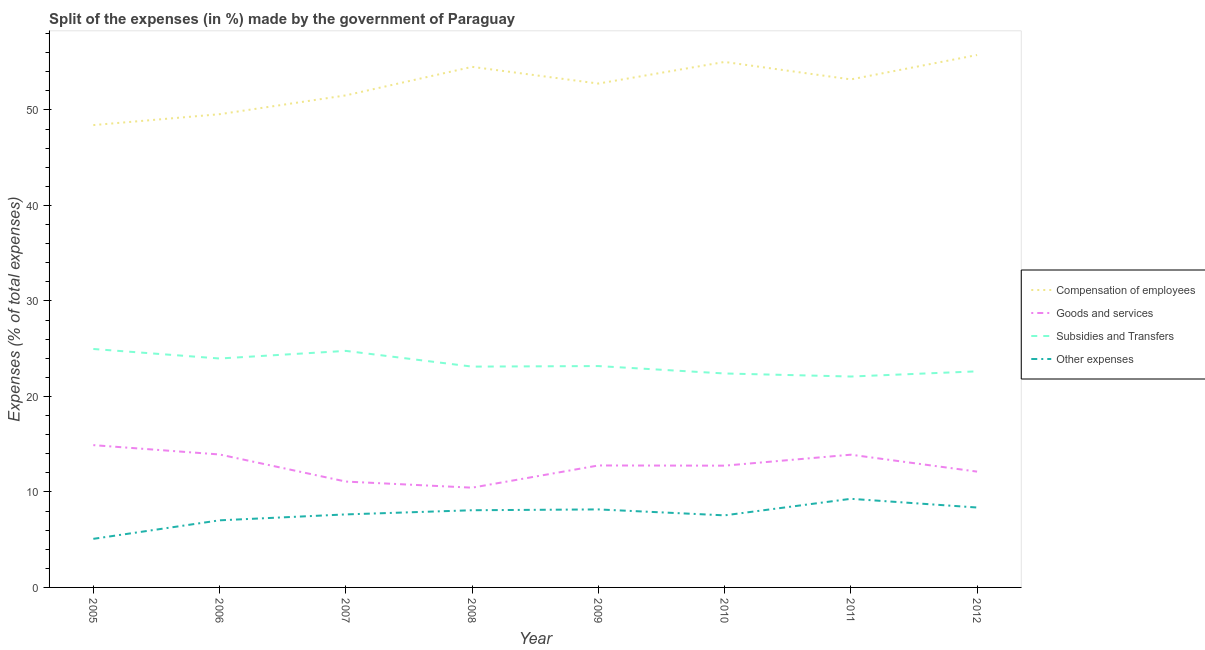Is the number of lines equal to the number of legend labels?
Provide a short and direct response. Yes. What is the percentage of amount spent on subsidies in 2005?
Give a very brief answer. 24.97. Across all years, what is the maximum percentage of amount spent on subsidies?
Provide a succinct answer. 24.97. Across all years, what is the minimum percentage of amount spent on other expenses?
Your answer should be very brief. 5.09. In which year was the percentage of amount spent on other expenses minimum?
Keep it short and to the point. 2005. What is the total percentage of amount spent on goods and services in the graph?
Offer a terse response. 101.9. What is the difference between the percentage of amount spent on subsidies in 2005 and that in 2007?
Your response must be concise. 0.2. What is the difference between the percentage of amount spent on goods and services in 2009 and the percentage of amount spent on compensation of employees in 2006?
Keep it short and to the point. -36.78. What is the average percentage of amount spent on goods and services per year?
Your answer should be compact. 12.74. In the year 2006, what is the difference between the percentage of amount spent on goods and services and percentage of amount spent on compensation of employees?
Provide a short and direct response. -35.63. What is the ratio of the percentage of amount spent on compensation of employees in 2006 to that in 2010?
Offer a very short reply. 0.9. Is the percentage of amount spent on compensation of employees in 2006 less than that in 2007?
Make the answer very short. Yes. What is the difference between the highest and the second highest percentage of amount spent on other expenses?
Offer a terse response. 0.91. What is the difference between the highest and the lowest percentage of amount spent on compensation of employees?
Give a very brief answer. 7.34. In how many years, is the percentage of amount spent on compensation of employees greater than the average percentage of amount spent on compensation of employees taken over all years?
Ensure brevity in your answer.  5. Is it the case that in every year, the sum of the percentage of amount spent on goods and services and percentage of amount spent on subsidies is greater than the sum of percentage of amount spent on other expenses and percentage of amount spent on compensation of employees?
Keep it short and to the point. No. Is the percentage of amount spent on compensation of employees strictly less than the percentage of amount spent on goods and services over the years?
Make the answer very short. No. Does the graph contain grids?
Ensure brevity in your answer.  No. How many legend labels are there?
Your response must be concise. 4. How are the legend labels stacked?
Your answer should be compact. Vertical. What is the title of the graph?
Offer a very short reply. Split of the expenses (in %) made by the government of Paraguay. Does "Quality of public administration" appear as one of the legend labels in the graph?
Offer a terse response. No. What is the label or title of the Y-axis?
Provide a short and direct response. Expenses (% of total expenses). What is the Expenses (% of total expenses) of Compensation of employees in 2005?
Ensure brevity in your answer.  48.42. What is the Expenses (% of total expenses) in Goods and services in 2005?
Ensure brevity in your answer.  14.9. What is the Expenses (% of total expenses) of Subsidies and Transfers in 2005?
Keep it short and to the point. 24.97. What is the Expenses (% of total expenses) of Other expenses in 2005?
Your answer should be compact. 5.09. What is the Expenses (% of total expenses) of Compensation of employees in 2006?
Offer a terse response. 49.56. What is the Expenses (% of total expenses) of Goods and services in 2006?
Keep it short and to the point. 13.92. What is the Expenses (% of total expenses) in Subsidies and Transfers in 2006?
Ensure brevity in your answer.  23.97. What is the Expenses (% of total expenses) in Other expenses in 2006?
Keep it short and to the point. 7.03. What is the Expenses (% of total expenses) of Compensation of employees in 2007?
Ensure brevity in your answer.  51.53. What is the Expenses (% of total expenses) of Goods and services in 2007?
Offer a very short reply. 11.09. What is the Expenses (% of total expenses) in Subsidies and Transfers in 2007?
Your answer should be very brief. 24.77. What is the Expenses (% of total expenses) in Other expenses in 2007?
Provide a succinct answer. 7.65. What is the Expenses (% of total expenses) of Compensation of employees in 2008?
Offer a very short reply. 54.52. What is the Expenses (% of total expenses) in Goods and services in 2008?
Make the answer very short. 10.45. What is the Expenses (% of total expenses) in Subsidies and Transfers in 2008?
Your answer should be compact. 23.12. What is the Expenses (% of total expenses) of Other expenses in 2008?
Your answer should be compact. 8.08. What is the Expenses (% of total expenses) in Compensation of employees in 2009?
Your answer should be very brief. 52.77. What is the Expenses (% of total expenses) of Goods and services in 2009?
Give a very brief answer. 12.77. What is the Expenses (% of total expenses) of Subsidies and Transfers in 2009?
Provide a succinct answer. 23.18. What is the Expenses (% of total expenses) of Other expenses in 2009?
Give a very brief answer. 8.17. What is the Expenses (% of total expenses) in Compensation of employees in 2010?
Your answer should be very brief. 55.03. What is the Expenses (% of total expenses) in Goods and services in 2010?
Your response must be concise. 12.75. What is the Expenses (% of total expenses) of Subsidies and Transfers in 2010?
Offer a very short reply. 22.4. What is the Expenses (% of total expenses) of Other expenses in 2010?
Ensure brevity in your answer.  7.55. What is the Expenses (% of total expenses) in Compensation of employees in 2011?
Offer a terse response. 53.2. What is the Expenses (% of total expenses) in Goods and services in 2011?
Provide a short and direct response. 13.9. What is the Expenses (% of total expenses) in Subsidies and Transfers in 2011?
Your answer should be compact. 22.09. What is the Expenses (% of total expenses) in Other expenses in 2011?
Offer a terse response. 9.28. What is the Expenses (% of total expenses) in Compensation of employees in 2012?
Offer a terse response. 55.75. What is the Expenses (% of total expenses) of Goods and services in 2012?
Provide a succinct answer. 12.13. What is the Expenses (% of total expenses) in Subsidies and Transfers in 2012?
Your answer should be very brief. 22.63. What is the Expenses (% of total expenses) in Other expenses in 2012?
Ensure brevity in your answer.  8.37. Across all years, what is the maximum Expenses (% of total expenses) of Compensation of employees?
Provide a succinct answer. 55.75. Across all years, what is the maximum Expenses (% of total expenses) of Goods and services?
Provide a short and direct response. 14.9. Across all years, what is the maximum Expenses (% of total expenses) of Subsidies and Transfers?
Your answer should be compact. 24.97. Across all years, what is the maximum Expenses (% of total expenses) in Other expenses?
Your answer should be very brief. 9.28. Across all years, what is the minimum Expenses (% of total expenses) in Compensation of employees?
Provide a short and direct response. 48.42. Across all years, what is the minimum Expenses (% of total expenses) in Goods and services?
Ensure brevity in your answer.  10.45. Across all years, what is the minimum Expenses (% of total expenses) of Subsidies and Transfers?
Offer a terse response. 22.09. Across all years, what is the minimum Expenses (% of total expenses) in Other expenses?
Keep it short and to the point. 5.09. What is the total Expenses (% of total expenses) of Compensation of employees in the graph?
Give a very brief answer. 420.76. What is the total Expenses (% of total expenses) of Goods and services in the graph?
Offer a very short reply. 101.9. What is the total Expenses (% of total expenses) in Subsidies and Transfers in the graph?
Ensure brevity in your answer.  187.14. What is the total Expenses (% of total expenses) of Other expenses in the graph?
Your answer should be compact. 61.21. What is the difference between the Expenses (% of total expenses) in Compensation of employees in 2005 and that in 2006?
Your response must be concise. -1.14. What is the difference between the Expenses (% of total expenses) of Subsidies and Transfers in 2005 and that in 2006?
Give a very brief answer. 1. What is the difference between the Expenses (% of total expenses) in Other expenses in 2005 and that in 2006?
Provide a succinct answer. -1.94. What is the difference between the Expenses (% of total expenses) in Compensation of employees in 2005 and that in 2007?
Provide a short and direct response. -3.11. What is the difference between the Expenses (% of total expenses) in Goods and services in 2005 and that in 2007?
Your answer should be very brief. 3.82. What is the difference between the Expenses (% of total expenses) in Subsidies and Transfers in 2005 and that in 2007?
Your answer should be very brief. 0.2. What is the difference between the Expenses (% of total expenses) in Other expenses in 2005 and that in 2007?
Ensure brevity in your answer.  -2.56. What is the difference between the Expenses (% of total expenses) of Compensation of employees in 2005 and that in 2008?
Your answer should be compact. -6.1. What is the difference between the Expenses (% of total expenses) in Goods and services in 2005 and that in 2008?
Your answer should be very brief. 4.46. What is the difference between the Expenses (% of total expenses) of Subsidies and Transfers in 2005 and that in 2008?
Provide a short and direct response. 1.85. What is the difference between the Expenses (% of total expenses) in Other expenses in 2005 and that in 2008?
Provide a succinct answer. -3. What is the difference between the Expenses (% of total expenses) in Compensation of employees in 2005 and that in 2009?
Provide a short and direct response. -4.35. What is the difference between the Expenses (% of total expenses) of Goods and services in 2005 and that in 2009?
Ensure brevity in your answer.  2.13. What is the difference between the Expenses (% of total expenses) of Subsidies and Transfers in 2005 and that in 2009?
Your answer should be very brief. 1.79. What is the difference between the Expenses (% of total expenses) of Other expenses in 2005 and that in 2009?
Provide a short and direct response. -3.08. What is the difference between the Expenses (% of total expenses) in Compensation of employees in 2005 and that in 2010?
Your response must be concise. -6.61. What is the difference between the Expenses (% of total expenses) of Goods and services in 2005 and that in 2010?
Offer a terse response. 2.15. What is the difference between the Expenses (% of total expenses) in Subsidies and Transfers in 2005 and that in 2010?
Provide a short and direct response. 2.56. What is the difference between the Expenses (% of total expenses) of Other expenses in 2005 and that in 2010?
Make the answer very short. -2.46. What is the difference between the Expenses (% of total expenses) in Compensation of employees in 2005 and that in 2011?
Give a very brief answer. -4.78. What is the difference between the Expenses (% of total expenses) of Goods and services in 2005 and that in 2011?
Ensure brevity in your answer.  1. What is the difference between the Expenses (% of total expenses) in Subsidies and Transfers in 2005 and that in 2011?
Give a very brief answer. 2.88. What is the difference between the Expenses (% of total expenses) of Other expenses in 2005 and that in 2011?
Your answer should be compact. -4.19. What is the difference between the Expenses (% of total expenses) of Compensation of employees in 2005 and that in 2012?
Your answer should be compact. -7.34. What is the difference between the Expenses (% of total expenses) in Goods and services in 2005 and that in 2012?
Offer a very short reply. 2.77. What is the difference between the Expenses (% of total expenses) of Subsidies and Transfers in 2005 and that in 2012?
Your answer should be very brief. 2.34. What is the difference between the Expenses (% of total expenses) of Other expenses in 2005 and that in 2012?
Your response must be concise. -3.28. What is the difference between the Expenses (% of total expenses) in Compensation of employees in 2006 and that in 2007?
Ensure brevity in your answer.  -1.97. What is the difference between the Expenses (% of total expenses) in Goods and services in 2006 and that in 2007?
Your response must be concise. 2.84. What is the difference between the Expenses (% of total expenses) of Subsidies and Transfers in 2006 and that in 2007?
Keep it short and to the point. -0.8. What is the difference between the Expenses (% of total expenses) of Other expenses in 2006 and that in 2007?
Offer a very short reply. -0.62. What is the difference between the Expenses (% of total expenses) in Compensation of employees in 2006 and that in 2008?
Give a very brief answer. -4.96. What is the difference between the Expenses (% of total expenses) in Goods and services in 2006 and that in 2008?
Provide a succinct answer. 3.48. What is the difference between the Expenses (% of total expenses) of Subsidies and Transfers in 2006 and that in 2008?
Ensure brevity in your answer.  0.85. What is the difference between the Expenses (% of total expenses) in Other expenses in 2006 and that in 2008?
Provide a succinct answer. -1.06. What is the difference between the Expenses (% of total expenses) in Compensation of employees in 2006 and that in 2009?
Your answer should be compact. -3.21. What is the difference between the Expenses (% of total expenses) in Goods and services in 2006 and that in 2009?
Provide a short and direct response. 1.15. What is the difference between the Expenses (% of total expenses) of Subsidies and Transfers in 2006 and that in 2009?
Give a very brief answer. 0.79. What is the difference between the Expenses (% of total expenses) of Other expenses in 2006 and that in 2009?
Ensure brevity in your answer.  -1.14. What is the difference between the Expenses (% of total expenses) of Compensation of employees in 2006 and that in 2010?
Keep it short and to the point. -5.47. What is the difference between the Expenses (% of total expenses) in Goods and services in 2006 and that in 2010?
Provide a succinct answer. 1.17. What is the difference between the Expenses (% of total expenses) of Subsidies and Transfers in 2006 and that in 2010?
Your answer should be compact. 1.57. What is the difference between the Expenses (% of total expenses) in Other expenses in 2006 and that in 2010?
Provide a short and direct response. -0.52. What is the difference between the Expenses (% of total expenses) in Compensation of employees in 2006 and that in 2011?
Your answer should be very brief. -3.64. What is the difference between the Expenses (% of total expenses) of Goods and services in 2006 and that in 2011?
Your response must be concise. 0.02. What is the difference between the Expenses (% of total expenses) in Subsidies and Transfers in 2006 and that in 2011?
Offer a terse response. 1.89. What is the difference between the Expenses (% of total expenses) in Other expenses in 2006 and that in 2011?
Give a very brief answer. -2.25. What is the difference between the Expenses (% of total expenses) in Compensation of employees in 2006 and that in 2012?
Give a very brief answer. -6.2. What is the difference between the Expenses (% of total expenses) in Goods and services in 2006 and that in 2012?
Your response must be concise. 1.8. What is the difference between the Expenses (% of total expenses) in Subsidies and Transfers in 2006 and that in 2012?
Provide a short and direct response. 1.34. What is the difference between the Expenses (% of total expenses) in Other expenses in 2006 and that in 2012?
Provide a short and direct response. -1.34. What is the difference between the Expenses (% of total expenses) in Compensation of employees in 2007 and that in 2008?
Provide a succinct answer. -2.99. What is the difference between the Expenses (% of total expenses) of Goods and services in 2007 and that in 2008?
Make the answer very short. 0.64. What is the difference between the Expenses (% of total expenses) of Subsidies and Transfers in 2007 and that in 2008?
Keep it short and to the point. 1.65. What is the difference between the Expenses (% of total expenses) in Other expenses in 2007 and that in 2008?
Keep it short and to the point. -0.44. What is the difference between the Expenses (% of total expenses) in Compensation of employees in 2007 and that in 2009?
Your response must be concise. -1.24. What is the difference between the Expenses (% of total expenses) of Goods and services in 2007 and that in 2009?
Offer a terse response. -1.69. What is the difference between the Expenses (% of total expenses) in Subsidies and Transfers in 2007 and that in 2009?
Your answer should be compact. 1.59. What is the difference between the Expenses (% of total expenses) in Other expenses in 2007 and that in 2009?
Your answer should be compact. -0.52. What is the difference between the Expenses (% of total expenses) of Compensation of employees in 2007 and that in 2010?
Keep it short and to the point. -3.5. What is the difference between the Expenses (% of total expenses) in Goods and services in 2007 and that in 2010?
Provide a short and direct response. -1.67. What is the difference between the Expenses (% of total expenses) in Subsidies and Transfers in 2007 and that in 2010?
Make the answer very short. 2.37. What is the difference between the Expenses (% of total expenses) of Other expenses in 2007 and that in 2010?
Keep it short and to the point. 0.1. What is the difference between the Expenses (% of total expenses) in Compensation of employees in 2007 and that in 2011?
Offer a terse response. -1.67. What is the difference between the Expenses (% of total expenses) in Goods and services in 2007 and that in 2011?
Offer a terse response. -2.81. What is the difference between the Expenses (% of total expenses) of Subsidies and Transfers in 2007 and that in 2011?
Keep it short and to the point. 2.69. What is the difference between the Expenses (% of total expenses) in Other expenses in 2007 and that in 2011?
Give a very brief answer. -1.63. What is the difference between the Expenses (% of total expenses) of Compensation of employees in 2007 and that in 2012?
Your answer should be very brief. -4.23. What is the difference between the Expenses (% of total expenses) of Goods and services in 2007 and that in 2012?
Offer a terse response. -1.04. What is the difference between the Expenses (% of total expenses) in Subsidies and Transfers in 2007 and that in 2012?
Provide a short and direct response. 2.14. What is the difference between the Expenses (% of total expenses) in Other expenses in 2007 and that in 2012?
Ensure brevity in your answer.  -0.72. What is the difference between the Expenses (% of total expenses) of Compensation of employees in 2008 and that in 2009?
Make the answer very short. 1.75. What is the difference between the Expenses (% of total expenses) of Goods and services in 2008 and that in 2009?
Provide a short and direct response. -2.33. What is the difference between the Expenses (% of total expenses) of Subsidies and Transfers in 2008 and that in 2009?
Offer a very short reply. -0.06. What is the difference between the Expenses (% of total expenses) of Other expenses in 2008 and that in 2009?
Ensure brevity in your answer.  -0.09. What is the difference between the Expenses (% of total expenses) in Compensation of employees in 2008 and that in 2010?
Ensure brevity in your answer.  -0.51. What is the difference between the Expenses (% of total expenses) of Goods and services in 2008 and that in 2010?
Offer a terse response. -2.31. What is the difference between the Expenses (% of total expenses) of Subsidies and Transfers in 2008 and that in 2010?
Keep it short and to the point. 0.72. What is the difference between the Expenses (% of total expenses) of Other expenses in 2008 and that in 2010?
Your response must be concise. 0.54. What is the difference between the Expenses (% of total expenses) of Compensation of employees in 2008 and that in 2011?
Provide a short and direct response. 1.32. What is the difference between the Expenses (% of total expenses) in Goods and services in 2008 and that in 2011?
Your answer should be compact. -3.45. What is the difference between the Expenses (% of total expenses) of Subsidies and Transfers in 2008 and that in 2011?
Your answer should be compact. 1.04. What is the difference between the Expenses (% of total expenses) in Other expenses in 2008 and that in 2011?
Provide a short and direct response. -1.2. What is the difference between the Expenses (% of total expenses) in Compensation of employees in 2008 and that in 2012?
Offer a terse response. -1.24. What is the difference between the Expenses (% of total expenses) of Goods and services in 2008 and that in 2012?
Provide a short and direct response. -1.68. What is the difference between the Expenses (% of total expenses) in Subsidies and Transfers in 2008 and that in 2012?
Ensure brevity in your answer.  0.5. What is the difference between the Expenses (% of total expenses) of Other expenses in 2008 and that in 2012?
Offer a terse response. -0.29. What is the difference between the Expenses (% of total expenses) of Compensation of employees in 2009 and that in 2010?
Provide a short and direct response. -2.26. What is the difference between the Expenses (% of total expenses) of Goods and services in 2009 and that in 2010?
Give a very brief answer. 0.02. What is the difference between the Expenses (% of total expenses) of Subsidies and Transfers in 2009 and that in 2010?
Provide a succinct answer. 0.78. What is the difference between the Expenses (% of total expenses) in Other expenses in 2009 and that in 2010?
Make the answer very short. 0.62. What is the difference between the Expenses (% of total expenses) in Compensation of employees in 2009 and that in 2011?
Offer a terse response. -0.43. What is the difference between the Expenses (% of total expenses) in Goods and services in 2009 and that in 2011?
Your answer should be compact. -1.13. What is the difference between the Expenses (% of total expenses) of Subsidies and Transfers in 2009 and that in 2011?
Offer a terse response. 1.1. What is the difference between the Expenses (% of total expenses) of Other expenses in 2009 and that in 2011?
Give a very brief answer. -1.11. What is the difference between the Expenses (% of total expenses) of Compensation of employees in 2009 and that in 2012?
Your response must be concise. -2.99. What is the difference between the Expenses (% of total expenses) of Goods and services in 2009 and that in 2012?
Make the answer very short. 0.64. What is the difference between the Expenses (% of total expenses) of Subsidies and Transfers in 2009 and that in 2012?
Provide a short and direct response. 0.55. What is the difference between the Expenses (% of total expenses) in Other expenses in 2009 and that in 2012?
Your answer should be compact. -0.2. What is the difference between the Expenses (% of total expenses) in Compensation of employees in 2010 and that in 2011?
Keep it short and to the point. 1.83. What is the difference between the Expenses (% of total expenses) of Goods and services in 2010 and that in 2011?
Offer a very short reply. -1.15. What is the difference between the Expenses (% of total expenses) in Subsidies and Transfers in 2010 and that in 2011?
Your answer should be very brief. 0.32. What is the difference between the Expenses (% of total expenses) in Other expenses in 2010 and that in 2011?
Your answer should be compact. -1.73. What is the difference between the Expenses (% of total expenses) in Compensation of employees in 2010 and that in 2012?
Keep it short and to the point. -0.73. What is the difference between the Expenses (% of total expenses) in Goods and services in 2010 and that in 2012?
Offer a terse response. 0.62. What is the difference between the Expenses (% of total expenses) in Subsidies and Transfers in 2010 and that in 2012?
Provide a succinct answer. -0.22. What is the difference between the Expenses (% of total expenses) of Other expenses in 2010 and that in 2012?
Offer a terse response. -0.82. What is the difference between the Expenses (% of total expenses) in Compensation of employees in 2011 and that in 2012?
Make the answer very short. -2.55. What is the difference between the Expenses (% of total expenses) of Goods and services in 2011 and that in 2012?
Your response must be concise. 1.77. What is the difference between the Expenses (% of total expenses) in Subsidies and Transfers in 2011 and that in 2012?
Give a very brief answer. -0.54. What is the difference between the Expenses (% of total expenses) in Other expenses in 2011 and that in 2012?
Offer a very short reply. 0.91. What is the difference between the Expenses (% of total expenses) in Compensation of employees in 2005 and the Expenses (% of total expenses) in Goods and services in 2006?
Provide a short and direct response. 34.49. What is the difference between the Expenses (% of total expenses) of Compensation of employees in 2005 and the Expenses (% of total expenses) of Subsidies and Transfers in 2006?
Your answer should be compact. 24.44. What is the difference between the Expenses (% of total expenses) in Compensation of employees in 2005 and the Expenses (% of total expenses) in Other expenses in 2006?
Make the answer very short. 41.39. What is the difference between the Expenses (% of total expenses) in Goods and services in 2005 and the Expenses (% of total expenses) in Subsidies and Transfers in 2006?
Provide a succinct answer. -9.07. What is the difference between the Expenses (% of total expenses) in Goods and services in 2005 and the Expenses (% of total expenses) in Other expenses in 2006?
Ensure brevity in your answer.  7.87. What is the difference between the Expenses (% of total expenses) of Subsidies and Transfers in 2005 and the Expenses (% of total expenses) of Other expenses in 2006?
Provide a succinct answer. 17.94. What is the difference between the Expenses (% of total expenses) of Compensation of employees in 2005 and the Expenses (% of total expenses) of Goods and services in 2007?
Offer a very short reply. 37.33. What is the difference between the Expenses (% of total expenses) of Compensation of employees in 2005 and the Expenses (% of total expenses) of Subsidies and Transfers in 2007?
Your answer should be compact. 23.64. What is the difference between the Expenses (% of total expenses) of Compensation of employees in 2005 and the Expenses (% of total expenses) of Other expenses in 2007?
Keep it short and to the point. 40.77. What is the difference between the Expenses (% of total expenses) of Goods and services in 2005 and the Expenses (% of total expenses) of Subsidies and Transfers in 2007?
Your response must be concise. -9.87. What is the difference between the Expenses (% of total expenses) of Goods and services in 2005 and the Expenses (% of total expenses) of Other expenses in 2007?
Your answer should be very brief. 7.25. What is the difference between the Expenses (% of total expenses) of Subsidies and Transfers in 2005 and the Expenses (% of total expenses) of Other expenses in 2007?
Give a very brief answer. 17.32. What is the difference between the Expenses (% of total expenses) of Compensation of employees in 2005 and the Expenses (% of total expenses) of Goods and services in 2008?
Your answer should be compact. 37.97. What is the difference between the Expenses (% of total expenses) of Compensation of employees in 2005 and the Expenses (% of total expenses) of Subsidies and Transfers in 2008?
Provide a short and direct response. 25.29. What is the difference between the Expenses (% of total expenses) in Compensation of employees in 2005 and the Expenses (% of total expenses) in Other expenses in 2008?
Give a very brief answer. 40.33. What is the difference between the Expenses (% of total expenses) in Goods and services in 2005 and the Expenses (% of total expenses) in Subsidies and Transfers in 2008?
Make the answer very short. -8.22. What is the difference between the Expenses (% of total expenses) in Goods and services in 2005 and the Expenses (% of total expenses) in Other expenses in 2008?
Your answer should be very brief. 6.82. What is the difference between the Expenses (% of total expenses) of Subsidies and Transfers in 2005 and the Expenses (% of total expenses) of Other expenses in 2008?
Your answer should be compact. 16.89. What is the difference between the Expenses (% of total expenses) in Compensation of employees in 2005 and the Expenses (% of total expenses) in Goods and services in 2009?
Your answer should be very brief. 35.64. What is the difference between the Expenses (% of total expenses) in Compensation of employees in 2005 and the Expenses (% of total expenses) in Subsidies and Transfers in 2009?
Ensure brevity in your answer.  25.23. What is the difference between the Expenses (% of total expenses) of Compensation of employees in 2005 and the Expenses (% of total expenses) of Other expenses in 2009?
Make the answer very short. 40.25. What is the difference between the Expenses (% of total expenses) in Goods and services in 2005 and the Expenses (% of total expenses) in Subsidies and Transfers in 2009?
Your response must be concise. -8.28. What is the difference between the Expenses (% of total expenses) in Goods and services in 2005 and the Expenses (% of total expenses) in Other expenses in 2009?
Provide a short and direct response. 6.73. What is the difference between the Expenses (% of total expenses) in Subsidies and Transfers in 2005 and the Expenses (% of total expenses) in Other expenses in 2009?
Your answer should be compact. 16.8. What is the difference between the Expenses (% of total expenses) of Compensation of employees in 2005 and the Expenses (% of total expenses) of Goods and services in 2010?
Your answer should be very brief. 35.66. What is the difference between the Expenses (% of total expenses) of Compensation of employees in 2005 and the Expenses (% of total expenses) of Subsidies and Transfers in 2010?
Keep it short and to the point. 26.01. What is the difference between the Expenses (% of total expenses) of Compensation of employees in 2005 and the Expenses (% of total expenses) of Other expenses in 2010?
Ensure brevity in your answer.  40.87. What is the difference between the Expenses (% of total expenses) in Goods and services in 2005 and the Expenses (% of total expenses) in Subsidies and Transfers in 2010?
Your answer should be compact. -7.5. What is the difference between the Expenses (% of total expenses) of Goods and services in 2005 and the Expenses (% of total expenses) of Other expenses in 2010?
Keep it short and to the point. 7.35. What is the difference between the Expenses (% of total expenses) in Subsidies and Transfers in 2005 and the Expenses (% of total expenses) in Other expenses in 2010?
Your response must be concise. 17.42. What is the difference between the Expenses (% of total expenses) in Compensation of employees in 2005 and the Expenses (% of total expenses) in Goods and services in 2011?
Provide a succinct answer. 34.52. What is the difference between the Expenses (% of total expenses) in Compensation of employees in 2005 and the Expenses (% of total expenses) in Subsidies and Transfers in 2011?
Provide a succinct answer. 26.33. What is the difference between the Expenses (% of total expenses) of Compensation of employees in 2005 and the Expenses (% of total expenses) of Other expenses in 2011?
Keep it short and to the point. 39.14. What is the difference between the Expenses (% of total expenses) of Goods and services in 2005 and the Expenses (% of total expenses) of Subsidies and Transfers in 2011?
Give a very brief answer. -7.18. What is the difference between the Expenses (% of total expenses) in Goods and services in 2005 and the Expenses (% of total expenses) in Other expenses in 2011?
Offer a terse response. 5.62. What is the difference between the Expenses (% of total expenses) in Subsidies and Transfers in 2005 and the Expenses (% of total expenses) in Other expenses in 2011?
Your answer should be very brief. 15.69. What is the difference between the Expenses (% of total expenses) in Compensation of employees in 2005 and the Expenses (% of total expenses) in Goods and services in 2012?
Keep it short and to the point. 36.29. What is the difference between the Expenses (% of total expenses) of Compensation of employees in 2005 and the Expenses (% of total expenses) of Subsidies and Transfers in 2012?
Offer a very short reply. 25.79. What is the difference between the Expenses (% of total expenses) of Compensation of employees in 2005 and the Expenses (% of total expenses) of Other expenses in 2012?
Ensure brevity in your answer.  40.05. What is the difference between the Expenses (% of total expenses) of Goods and services in 2005 and the Expenses (% of total expenses) of Subsidies and Transfers in 2012?
Your answer should be very brief. -7.73. What is the difference between the Expenses (% of total expenses) in Goods and services in 2005 and the Expenses (% of total expenses) in Other expenses in 2012?
Provide a short and direct response. 6.53. What is the difference between the Expenses (% of total expenses) in Subsidies and Transfers in 2005 and the Expenses (% of total expenses) in Other expenses in 2012?
Offer a terse response. 16.6. What is the difference between the Expenses (% of total expenses) in Compensation of employees in 2006 and the Expenses (% of total expenses) in Goods and services in 2007?
Give a very brief answer. 38.47. What is the difference between the Expenses (% of total expenses) in Compensation of employees in 2006 and the Expenses (% of total expenses) in Subsidies and Transfers in 2007?
Your answer should be very brief. 24.78. What is the difference between the Expenses (% of total expenses) of Compensation of employees in 2006 and the Expenses (% of total expenses) of Other expenses in 2007?
Make the answer very short. 41.91. What is the difference between the Expenses (% of total expenses) in Goods and services in 2006 and the Expenses (% of total expenses) in Subsidies and Transfers in 2007?
Give a very brief answer. -10.85. What is the difference between the Expenses (% of total expenses) in Goods and services in 2006 and the Expenses (% of total expenses) in Other expenses in 2007?
Your answer should be compact. 6.28. What is the difference between the Expenses (% of total expenses) of Subsidies and Transfers in 2006 and the Expenses (% of total expenses) of Other expenses in 2007?
Ensure brevity in your answer.  16.33. What is the difference between the Expenses (% of total expenses) in Compensation of employees in 2006 and the Expenses (% of total expenses) in Goods and services in 2008?
Provide a succinct answer. 39.11. What is the difference between the Expenses (% of total expenses) of Compensation of employees in 2006 and the Expenses (% of total expenses) of Subsidies and Transfers in 2008?
Provide a short and direct response. 26.43. What is the difference between the Expenses (% of total expenses) in Compensation of employees in 2006 and the Expenses (% of total expenses) in Other expenses in 2008?
Your answer should be compact. 41.47. What is the difference between the Expenses (% of total expenses) of Goods and services in 2006 and the Expenses (% of total expenses) of Subsidies and Transfers in 2008?
Offer a terse response. -9.2. What is the difference between the Expenses (% of total expenses) in Goods and services in 2006 and the Expenses (% of total expenses) in Other expenses in 2008?
Your answer should be very brief. 5.84. What is the difference between the Expenses (% of total expenses) in Subsidies and Transfers in 2006 and the Expenses (% of total expenses) in Other expenses in 2008?
Provide a succinct answer. 15.89. What is the difference between the Expenses (% of total expenses) in Compensation of employees in 2006 and the Expenses (% of total expenses) in Goods and services in 2009?
Keep it short and to the point. 36.78. What is the difference between the Expenses (% of total expenses) in Compensation of employees in 2006 and the Expenses (% of total expenses) in Subsidies and Transfers in 2009?
Make the answer very short. 26.37. What is the difference between the Expenses (% of total expenses) of Compensation of employees in 2006 and the Expenses (% of total expenses) of Other expenses in 2009?
Keep it short and to the point. 41.39. What is the difference between the Expenses (% of total expenses) of Goods and services in 2006 and the Expenses (% of total expenses) of Subsidies and Transfers in 2009?
Keep it short and to the point. -9.26. What is the difference between the Expenses (% of total expenses) of Goods and services in 2006 and the Expenses (% of total expenses) of Other expenses in 2009?
Provide a short and direct response. 5.75. What is the difference between the Expenses (% of total expenses) in Subsidies and Transfers in 2006 and the Expenses (% of total expenses) in Other expenses in 2009?
Provide a short and direct response. 15.8. What is the difference between the Expenses (% of total expenses) in Compensation of employees in 2006 and the Expenses (% of total expenses) in Goods and services in 2010?
Provide a succinct answer. 36.8. What is the difference between the Expenses (% of total expenses) in Compensation of employees in 2006 and the Expenses (% of total expenses) in Subsidies and Transfers in 2010?
Keep it short and to the point. 27.15. What is the difference between the Expenses (% of total expenses) in Compensation of employees in 2006 and the Expenses (% of total expenses) in Other expenses in 2010?
Make the answer very short. 42.01. What is the difference between the Expenses (% of total expenses) of Goods and services in 2006 and the Expenses (% of total expenses) of Subsidies and Transfers in 2010?
Your answer should be very brief. -8.48. What is the difference between the Expenses (% of total expenses) in Goods and services in 2006 and the Expenses (% of total expenses) in Other expenses in 2010?
Offer a very short reply. 6.38. What is the difference between the Expenses (% of total expenses) of Subsidies and Transfers in 2006 and the Expenses (% of total expenses) of Other expenses in 2010?
Offer a very short reply. 16.43. What is the difference between the Expenses (% of total expenses) in Compensation of employees in 2006 and the Expenses (% of total expenses) in Goods and services in 2011?
Offer a terse response. 35.66. What is the difference between the Expenses (% of total expenses) of Compensation of employees in 2006 and the Expenses (% of total expenses) of Subsidies and Transfers in 2011?
Make the answer very short. 27.47. What is the difference between the Expenses (% of total expenses) in Compensation of employees in 2006 and the Expenses (% of total expenses) in Other expenses in 2011?
Provide a succinct answer. 40.28. What is the difference between the Expenses (% of total expenses) in Goods and services in 2006 and the Expenses (% of total expenses) in Subsidies and Transfers in 2011?
Keep it short and to the point. -8.16. What is the difference between the Expenses (% of total expenses) in Goods and services in 2006 and the Expenses (% of total expenses) in Other expenses in 2011?
Offer a terse response. 4.64. What is the difference between the Expenses (% of total expenses) of Subsidies and Transfers in 2006 and the Expenses (% of total expenses) of Other expenses in 2011?
Make the answer very short. 14.69. What is the difference between the Expenses (% of total expenses) of Compensation of employees in 2006 and the Expenses (% of total expenses) of Goods and services in 2012?
Make the answer very short. 37.43. What is the difference between the Expenses (% of total expenses) of Compensation of employees in 2006 and the Expenses (% of total expenses) of Subsidies and Transfers in 2012?
Offer a very short reply. 26.93. What is the difference between the Expenses (% of total expenses) in Compensation of employees in 2006 and the Expenses (% of total expenses) in Other expenses in 2012?
Provide a short and direct response. 41.19. What is the difference between the Expenses (% of total expenses) of Goods and services in 2006 and the Expenses (% of total expenses) of Subsidies and Transfers in 2012?
Your answer should be very brief. -8.71. What is the difference between the Expenses (% of total expenses) in Goods and services in 2006 and the Expenses (% of total expenses) in Other expenses in 2012?
Your answer should be compact. 5.55. What is the difference between the Expenses (% of total expenses) in Subsidies and Transfers in 2006 and the Expenses (% of total expenses) in Other expenses in 2012?
Offer a very short reply. 15.6. What is the difference between the Expenses (% of total expenses) of Compensation of employees in 2007 and the Expenses (% of total expenses) of Goods and services in 2008?
Your answer should be compact. 41.08. What is the difference between the Expenses (% of total expenses) of Compensation of employees in 2007 and the Expenses (% of total expenses) of Subsidies and Transfers in 2008?
Keep it short and to the point. 28.4. What is the difference between the Expenses (% of total expenses) of Compensation of employees in 2007 and the Expenses (% of total expenses) of Other expenses in 2008?
Ensure brevity in your answer.  43.44. What is the difference between the Expenses (% of total expenses) of Goods and services in 2007 and the Expenses (% of total expenses) of Subsidies and Transfers in 2008?
Offer a terse response. -12.04. What is the difference between the Expenses (% of total expenses) in Goods and services in 2007 and the Expenses (% of total expenses) in Other expenses in 2008?
Give a very brief answer. 3. What is the difference between the Expenses (% of total expenses) of Subsidies and Transfers in 2007 and the Expenses (% of total expenses) of Other expenses in 2008?
Offer a very short reply. 16.69. What is the difference between the Expenses (% of total expenses) of Compensation of employees in 2007 and the Expenses (% of total expenses) of Goods and services in 2009?
Give a very brief answer. 38.76. What is the difference between the Expenses (% of total expenses) of Compensation of employees in 2007 and the Expenses (% of total expenses) of Subsidies and Transfers in 2009?
Make the answer very short. 28.35. What is the difference between the Expenses (% of total expenses) in Compensation of employees in 2007 and the Expenses (% of total expenses) in Other expenses in 2009?
Offer a terse response. 43.36. What is the difference between the Expenses (% of total expenses) in Goods and services in 2007 and the Expenses (% of total expenses) in Subsidies and Transfers in 2009?
Ensure brevity in your answer.  -12.1. What is the difference between the Expenses (% of total expenses) of Goods and services in 2007 and the Expenses (% of total expenses) of Other expenses in 2009?
Offer a very short reply. 2.92. What is the difference between the Expenses (% of total expenses) of Subsidies and Transfers in 2007 and the Expenses (% of total expenses) of Other expenses in 2009?
Your answer should be compact. 16.6. What is the difference between the Expenses (% of total expenses) in Compensation of employees in 2007 and the Expenses (% of total expenses) in Goods and services in 2010?
Your answer should be compact. 38.78. What is the difference between the Expenses (% of total expenses) of Compensation of employees in 2007 and the Expenses (% of total expenses) of Subsidies and Transfers in 2010?
Give a very brief answer. 29.12. What is the difference between the Expenses (% of total expenses) in Compensation of employees in 2007 and the Expenses (% of total expenses) in Other expenses in 2010?
Your answer should be compact. 43.98. What is the difference between the Expenses (% of total expenses) in Goods and services in 2007 and the Expenses (% of total expenses) in Subsidies and Transfers in 2010?
Provide a succinct answer. -11.32. What is the difference between the Expenses (% of total expenses) of Goods and services in 2007 and the Expenses (% of total expenses) of Other expenses in 2010?
Your answer should be compact. 3.54. What is the difference between the Expenses (% of total expenses) of Subsidies and Transfers in 2007 and the Expenses (% of total expenses) of Other expenses in 2010?
Your response must be concise. 17.22. What is the difference between the Expenses (% of total expenses) in Compensation of employees in 2007 and the Expenses (% of total expenses) in Goods and services in 2011?
Offer a terse response. 37.63. What is the difference between the Expenses (% of total expenses) of Compensation of employees in 2007 and the Expenses (% of total expenses) of Subsidies and Transfers in 2011?
Provide a succinct answer. 29.44. What is the difference between the Expenses (% of total expenses) in Compensation of employees in 2007 and the Expenses (% of total expenses) in Other expenses in 2011?
Keep it short and to the point. 42.25. What is the difference between the Expenses (% of total expenses) in Goods and services in 2007 and the Expenses (% of total expenses) in Subsidies and Transfers in 2011?
Give a very brief answer. -11. What is the difference between the Expenses (% of total expenses) in Goods and services in 2007 and the Expenses (% of total expenses) in Other expenses in 2011?
Keep it short and to the point. 1.81. What is the difference between the Expenses (% of total expenses) in Subsidies and Transfers in 2007 and the Expenses (% of total expenses) in Other expenses in 2011?
Your answer should be very brief. 15.49. What is the difference between the Expenses (% of total expenses) of Compensation of employees in 2007 and the Expenses (% of total expenses) of Goods and services in 2012?
Offer a terse response. 39.4. What is the difference between the Expenses (% of total expenses) of Compensation of employees in 2007 and the Expenses (% of total expenses) of Subsidies and Transfers in 2012?
Offer a very short reply. 28.9. What is the difference between the Expenses (% of total expenses) in Compensation of employees in 2007 and the Expenses (% of total expenses) in Other expenses in 2012?
Provide a short and direct response. 43.16. What is the difference between the Expenses (% of total expenses) in Goods and services in 2007 and the Expenses (% of total expenses) in Subsidies and Transfers in 2012?
Your answer should be compact. -11.54. What is the difference between the Expenses (% of total expenses) in Goods and services in 2007 and the Expenses (% of total expenses) in Other expenses in 2012?
Offer a terse response. 2.72. What is the difference between the Expenses (% of total expenses) of Subsidies and Transfers in 2007 and the Expenses (% of total expenses) of Other expenses in 2012?
Offer a terse response. 16.4. What is the difference between the Expenses (% of total expenses) of Compensation of employees in 2008 and the Expenses (% of total expenses) of Goods and services in 2009?
Ensure brevity in your answer.  41.74. What is the difference between the Expenses (% of total expenses) in Compensation of employees in 2008 and the Expenses (% of total expenses) in Subsidies and Transfers in 2009?
Keep it short and to the point. 31.33. What is the difference between the Expenses (% of total expenses) of Compensation of employees in 2008 and the Expenses (% of total expenses) of Other expenses in 2009?
Provide a succinct answer. 46.35. What is the difference between the Expenses (% of total expenses) of Goods and services in 2008 and the Expenses (% of total expenses) of Subsidies and Transfers in 2009?
Keep it short and to the point. -12.74. What is the difference between the Expenses (% of total expenses) of Goods and services in 2008 and the Expenses (% of total expenses) of Other expenses in 2009?
Provide a succinct answer. 2.28. What is the difference between the Expenses (% of total expenses) in Subsidies and Transfers in 2008 and the Expenses (% of total expenses) in Other expenses in 2009?
Make the answer very short. 14.95. What is the difference between the Expenses (% of total expenses) of Compensation of employees in 2008 and the Expenses (% of total expenses) of Goods and services in 2010?
Provide a short and direct response. 41.76. What is the difference between the Expenses (% of total expenses) in Compensation of employees in 2008 and the Expenses (% of total expenses) in Subsidies and Transfers in 2010?
Ensure brevity in your answer.  32.11. What is the difference between the Expenses (% of total expenses) of Compensation of employees in 2008 and the Expenses (% of total expenses) of Other expenses in 2010?
Your response must be concise. 46.97. What is the difference between the Expenses (% of total expenses) in Goods and services in 2008 and the Expenses (% of total expenses) in Subsidies and Transfers in 2010?
Offer a terse response. -11.96. What is the difference between the Expenses (% of total expenses) of Goods and services in 2008 and the Expenses (% of total expenses) of Other expenses in 2010?
Make the answer very short. 2.9. What is the difference between the Expenses (% of total expenses) in Subsidies and Transfers in 2008 and the Expenses (% of total expenses) in Other expenses in 2010?
Provide a succinct answer. 15.58. What is the difference between the Expenses (% of total expenses) of Compensation of employees in 2008 and the Expenses (% of total expenses) of Goods and services in 2011?
Your response must be concise. 40.62. What is the difference between the Expenses (% of total expenses) of Compensation of employees in 2008 and the Expenses (% of total expenses) of Subsidies and Transfers in 2011?
Offer a terse response. 32.43. What is the difference between the Expenses (% of total expenses) of Compensation of employees in 2008 and the Expenses (% of total expenses) of Other expenses in 2011?
Give a very brief answer. 45.24. What is the difference between the Expenses (% of total expenses) in Goods and services in 2008 and the Expenses (% of total expenses) in Subsidies and Transfers in 2011?
Provide a short and direct response. -11.64. What is the difference between the Expenses (% of total expenses) in Goods and services in 2008 and the Expenses (% of total expenses) in Other expenses in 2011?
Your answer should be very brief. 1.17. What is the difference between the Expenses (% of total expenses) in Subsidies and Transfers in 2008 and the Expenses (% of total expenses) in Other expenses in 2011?
Ensure brevity in your answer.  13.84. What is the difference between the Expenses (% of total expenses) of Compensation of employees in 2008 and the Expenses (% of total expenses) of Goods and services in 2012?
Provide a succinct answer. 42.39. What is the difference between the Expenses (% of total expenses) in Compensation of employees in 2008 and the Expenses (% of total expenses) in Subsidies and Transfers in 2012?
Your answer should be compact. 31.89. What is the difference between the Expenses (% of total expenses) of Compensation of employees in 2008 and the Expenses (% of total expenses) of Other expenses in 2012?
Provide a succinct answer. 46.15. What is the difference between the Expenses (% of total expenses) in Goods and services in 2008 and the Expenses (% of total expenses) in Subsidies and Transfers in 2012?
Offer a terse response. -12.18. What is the difference between the Expenses (% of total expenses) in Goods and services in 2008 and the Expenses (% of total expenses) in Other expenses in 2012?
Provide a succinct answer. 2.08. What is the difference between the Expenses (% of total expenses) in Subsidies and Transfers in 2008 and the Expenses (% of total expenses) in Other expenses in 2012?
Give a very brief answer. 14.76. What is the difference between the Expenses (% of total expenses) in Compensation of employees in 2009 and the Expenses (% of total expenses) in Goods and services in 2010?
Make the answer very short. 40.01. What is the difference between the Expenses (% of total expenses) of Compensation of employees in 2009 and the Expenses (% of total expenses) of Subsidies and Transfers in 2010?
Offer a terse response. 30.36. What is the difference between the Expenses (% of total expenses) of Compensation of employees in 2009 and the Expenses (% of total expenses) of Other expenses in 2010?
Give a very brief answer. 45.22. What is the difference between the Expenses (% of total expenses) of Goods and services in 2009 and the Expenses (% of total expenses) of Subsidies and Transfers in 2010?
Make the answer very short. -9.63. What is the difference between the Expenses (% of total expenses) of Goods and services in 2009 and the Expenses (% of total expenses) of Other expenses in 2010?
Offer a terse response. 5.22. What is the difference between the Expenses (% of total expenses) in Subsidies and Transfers in 2009 and the Expenses (% of total expenses) in Other expenses in 2010?
Make the answer very short. 15.63. What is the difference between the Expenses (% of total expenses) of Compensation of employees in 2009 and the Expenses (% of total expenses) of Goods and services in 2011?
Offer a very short reply. 38.87. What is the difference between the Expenses (% of total expenses) of Compensation of employees in 2009 and the Expenses (% of total expenses) of Subsidies and Transfers in 2011?
Offer a terse response. 30.68. What is the difference between the Expenses (% of total expenses) in Compensation of employees in 2009 and the Expenses (% of total expenses) in Other expenses in 2011?
Provide a short and direct response. 43.49. What is the difference between the Expenses (% of total expenses) of Goods and services in 2009 and the Expenses (% of total expenses) of Subsidies and Transfers in 2011?
Offer a very short reply. -9.31. What is the difference between the Expenses (% of total expenses) of Goods and services in 2009 and the Expenses (% of total expenses) of Other expenses in 2011?
Your answer should be very brief. 3.49. What is the difference between the Expenses (% of total expenses) of Subsidies and Transfers in 2009 and the Expenses (% of total expenses) of Other expenses in 2011?
Offer a very short reply. 13.9. What is the difference between the Expenses (% of total expenses) of Compensation of employees in 2009 and the Expenses (% of total expenses) of Goods and services in 2012?
Give a very brief answer. 40.64. What is the difference between the Expenses (% of total expenses) in Compensation of employees in 2009 and the Expenses (% of total expenses) in Subsidies and Transfers in 2012?
Your response must be concise. 30.14. What is the difference between the Expenses (% of total expenses) in Compensation of employees in 2009 and the Expenses (% of total expenses) in Other expenses in 2012?
Your response must be concise. 44.4. What is the difference between the Expenses (% of total expenses) in Goods and services in 2009 and the Expenses (% of total expenses) in Subsidies and Transfers in 2012?
Offer a terse response. -9.86. What is the difference between the Expenses (% of total expenses) in Goods and services in 2009 and the Expenses (% of total expenses) in Other expenses in 2012?
Your answer should be compact. 4.4. What is the difference between the Expenses (% of total expenses) in Subsidies and Transfers in 2009 and the Expenses (% of total expenses) in Other expenses in 2012?
Your answer should be compact. 14.81. What is the difference between the Expenses (% of total expenses) of Compensation of employees in 2010 and the Expenses (% of total expenses) of Goods and services in 2011?
Provide a short and direct response. 41.13. What is the difference between the Expenses (% of total expenses) of Compensation of employees in 2010 and the Expenses (% of total expenses) of Subsidies and Transfers in 2011?
Offer a terse response. 32.94. What is the difference between the Expenses (% of total expenses) in Compensation of employees in 2010 and the Expenses (% of total expenses) in Other expenses in 2011?
Offer a very short reply. 45.75. What is the difference between the Expenses (% of total expenses) of Goods and services in 2010 and the Expenses (% of total expenses) of Subsidies and Transfers in 2011?
Ensure brevity in your answer.  -9.33. What is the difference between the Expenses (% of total expenses) in Goods and services in 2010 and the Expenses (% of total expenses) in Other expenses in 2011?
Offer a very short reply. 3.47. What is the difference between the Expenses (% of total expenses) of Subsidies and Transfers in 2010 and the Expenses (% of total expenses) of Other expenses in 2011?
Provide a succinct answer. 13.13. What is the difference between the Expenses (% of total expenses) of Compensation of employees in 2010 and the Expenses (% of total expenses) of Goods and services in 2012?
Your answer should be very brief. 42.9. What is the difference between the Expenses (% of total expenses) of Compensation of employees in 2010 and the Expenses (% of total expenses) of Subsidies and Transfers in 2012?
Offer a terse response. 32.4. What is the difference between the Expenses (% of total expenses) of Compensation of employees in 2010 and the Expenses (% of total expenses) of Other expenses in 2012?
Make the answer very short. 46.66. What is the difference between the Expenses (% of total expenses) of Goods and services in 2010 and the Expenses (% of total expenses) of Subsidies and Transfers in 2012?
Your answer should be very brief. -9.88. What is the difference between the Expenses (% of total expenses) of Goods and services in 2010 and the Expenses (% of total expenses) of Other expenses in 2012?
Your response must be concise. 4.38. What is the difference between the Expenses (% of total expenses) in Subsidies and Transfers in 2010 and the Expenses (% of total expenses) in Other expenses in 2012?
Provide a short and direct response. 14.04. What is the difference between the Expenses (% of total expenses) of Compensation of employees in 2011 and the Expenses (% of total expenses) of Goods and services in 2012?
Offer a very short reply. 41.07. What is the difference between the Expenses (% of total expenses) in Compensation of employees in 2011 and the Expenses (% of total expenses) in Subsidies and Transfers in 2012?
Your answer should be compact. 30.57. What is the difference between the Expenses (% of total expenses) in Compensation of employees in 2011 and the Expenses (% of total expenses) in Other expenses in 2012?
Provide a short and direct response. 44.83. What is the difference between the Expenses (% of total expenses) in Goods and services in 2011 and the Expenses (% of total expenses) in Subsidies and Transfers in 2012?
Your response must be concise. -8.73. What is the difference between the Expenses (% of total expenses) in Goods and services in 2011 and the Expenses (% of total expenses) in Other expenses in 2012?
Keep it short and to the point. 5.53. What is the difference between the Expenses (% of total expenses) of Subsidies and Transfers in 2011 and the Expenses (% of total expenses) of Other expenses in 2012?
Offer a terse response. 13.72. What is the average Expenses (% of total expenses) of Compensation of employees per year?
Your answer should be compact. 52.6. What is the average Expenses (% of total expenses) in Goods and services per year?
Your answer should be compact. 12.74. What is the average Expenses (% of total expenses) of Subsidies and Transfers per year?
Your answer should be very brief. 23.39. What is the average Expenses (% of total expenses) of Other expenses per year?
Provide a succinct answer. 7.65. In the year 2005, what is the difference between the Expenses (% of total expenses) in Compensation of employees and Expenses (% of total expenses) in Goods and services?
Offer a very short reply. 33.52. In the year 2005, what is the difference between the Expenses (% of total expenses) of Compensation of employees and Expenses (% of total expenses) of Subsidies and Transfers?
Make the answer very short. 23.45. In the year 2005, what is the difference between the Expenses (% of total expenses) of Compensation of employees and Expenses (% of total expenses) of Other expenses?
Make the answer very short. 43.33. In the year 2005, what is the difference between the Expenses (% of total expenses) of Goods and services and Expenses (% of total expenses) of Subsidies and Transfers?
Your response must be concise. -10.07. In the year 2005, what is the difference between the Expenses (% of total expenses) in Goods and services and Expenses (% of total expenses) in Other expenses?
Provide a short and direct response. 9.81. In the year 2005, what is the difference between the Expenses (% of total expenses) of Subsidies and Transfers and Expenses (% of total expenses) of Other expenses?
Offer a terse response. 19.88. In the year 2006, what is the difference between the Expenses (% of total expenses) in Compensation of employees and Expenses (% of total expenses) in Goods and services?
Make the answer very short. 35.63. In the year 2006, what is the difference between the Expenses (% of total expenses) of Compensation of employees and Expenses (% of total expenses) of Subsidies and Transfers?
Keep it short and to the point. 25.58. In the year 2006, what is the difference between the Expenses (% of total expenses) in Compensation of employees and Expenses (% of total expenses) in Other expenses?
Your answer should be compact. 42.53. In the year 2006, what is the difference between the Expenses (% of total expenses) of Goods and services and Expenses (% of total expenses) of Subsidies and Transfers?
Offer a very short reply. -10.05. In the year 2006, what is the difference between the Expenses (% of total expenses) of Goods and services and Expenses (% of total expenses) of Other expenses?
Offer a very short reply. 6.9. In the year 2006, what is the difference between the Expenses (% of total expenses) of Subsidies and Transfers and Expenses (% of total expenses) of Other expenses?
Keep it short and to the point. 16.95. In the year 2007, what is the difference between the Expenses (% of total expenses) in Compensation of employees and Expenses (% of total expenses) in Goods and services?
Your answer should be very brief. 40.44. In the year 2007, what is the difference between the Expenses (% of total expenses) in Compensation of employees and Expenses (% of total expenses) in Subsidies and Transfers?
Provide a succinct answer. 26.76. In the year 2007, what is the difference between the Expenses (% of total expenses) in Compensation of employees and Expenses (% of total expenses) in Other expenses?
Provide a short and direct response. 43.88. In the year 2007, what is the difference between the Expenses (% of total expenses) in Goods and services and Expenses (% of total expenses) in Subsidies and Transfers?
Your answer should be very brief. -13.69. In the year 2007, what is the difference between the Expenses (% of total expenses) of Goods and services and Expenses (% of total expenses) of Other expenses?
Provide a succinct answer. 3.44. In the year 2007, what is the difference between the Expenses (% of total expenses) in Subsidies and Transfers and Expenses (% of total expenses) in Other expenses?
Offer a terse response. 17.13. In the year 2008, what is the difference between the Expenses (% of total expenses) in Compensation of employees and Expenses (% of total expenses) in Goods and services?
Make the answer very short. 44.07. In the year 2008, what is the difference between the Expenses (% of total expenses) of Compensation of employees and Expenses (% of total expenses) of Subsidies and Transfers?
Offer a very short reply. 31.39. In the year 2008, what is the difference between the Expenses (% of total expenses) in Compensation of employees and Expenses (% of total expenses) in Other expenses?
Provide a short and direct response. 46.43. In the year 2008, what is the difference between the Expenses (% of total expenses) of Goods and services and Expenses (% of total expenses) of Subsidies and Transfers?
Offer a terse response. -12.68. In the year 2008, what is the difference between the Expenses (% of total expenses) of Goods and services and Expenses (% of total expenses) of Other expenses?
Provide a short and direct response. 2.36. In the year 2008, what is the difference between the Expenses (% of total expenses) in Subsidies and Transfers and Expenses (% of total expenses) in Other expenses?
Your answer should be very brief. 15.04. In the year 2009, what is the difference between the Expenses (% of total expenses) of Compensation of employees and Expenses (% of total expenses) of Goods and services?
Offer a very short reply. 39.99. In the year 2009, what is the difference between the Expenses (% of total expenses) in Compensation of employees and Expenses (% of total expenses) in Subsidies and Transfers?
Offer a very short reply. 29.58. In the year 2009, what is the difference between the Expenses (% of total expenses) in Compensation of employees and Expenses (% of total expenses) in Other expenses?
Make the answer very short. 44.6. In the year 2009, what is the difference between the Expenses (% of total expenses) of Goods and services and Expenses (% of total expenses) of Subsidies and Transfers?
Ensure brevity in your answer.  -10.41. In the year 2009, what is the difference between the Expenses (% of total expenses) in Goods and services and Expenses (% of total expenses) in Other expenses?
Keep it short and to the point. 4.6. In the year 2009, what is the difference between the Expenses (% of total expenses) in Subsidies and Transfers and Expenses (% of total expenses) in Other expenses?
Your response must be concise. 15.01. In the year 2010, what is the difference between the Expenses (% of total expenses) in Compensation of employees and Expenses (% of total expenses) in Goods and services?
Your answer should be compact. 42.28. In the year 2010, what is the difference between the Expenses (% of total expenses) in Compensation of employees and Expenses (% of total expenses) in Subsidies and Transfers?
Your answer should be compact. 32.62. In the year 2010, what is the difference between the Expenses (% of total expenses) of Compensation of employees and Expenses (% of total expenses) of Other expenses?
Give a very brief answer. 47.48. In the year 2010, what is the difference between the Expenses (% of total expenses) of Goods and services and Expenses (% of total expenses) of Subsidies and Transfers?
Keep it short and to the point. -9.65. In the year 2010, what is the difference between the Expenses (% of total expenses) of Goods and services and Expenses (% of total expenses) of Other expenses?
Offer a very short reply. 5.2. In the year 2010, what is the difference between the Expenses (% of total expenses) of Subsidies and Transfers and Expenses (% of total expenses) of Other expenses?
Your answer should be very brief. 14.86. In the year 2011, what is the difference between the Expenses (% of total expenses) in Compensation of employees and Expenses (% of total expenses) in Goods and services?
Make the answer very short. 39.3. In the year 2011, what is the difference between the Expenses (% of total expenses) of Compensation of employees and Expenses (% of total expenses) of Subsidies and Transfers?
Keep it short and to the point. 31.11. In the year 2011, what is the difference between the Expenses (% of total expenses) of Compensation of employees and Expenses (% of total expenses) of Other expenses?
Make the answer very short. 43.92. In the year 2011, what is the difference between the Expenses (% of total expenses) in Goods and services and Expenses (% of total expenses) in Subsidies and Transfers?
Make the answer very short. -8.19. In the year 2011, what is the difference between the Expenses (% of total expenses) of Goods and services and Expenses (% of total expenses) of Other expenses?
Ensure brevity in your answer.  4.62. In the year 2011, what is the difference between the Expenses (% of total expenses) in Subsidies and Transfers and Expenses (% of total expenses) in Other expenses?
Give a very brief answer. 12.81. In the year 2012, what is the difference between the Expenses (% of total expenses) in Compensation of employees and Expenses (% of total expenses) in Goods and services?
Ensure brevity in your answer.  43.63. In the year 2012, what is the difference between the Expenses (% of total expenses) of Compensation of employees and Expenses (% of total expenses) of Subsidies and Transfers?
Make the answer very short. 33.13. In the year 2012, what is the difference between the Expenses (% of total expenses) in Compensation of employees and Expenses (% of total expenses) in Other expenses?
Your answer should be very brief. 47.39. In the year 2012, what is the difference between the Expenses (% of total expenses) of Goods and services and Expenses (% of total expenses) of Subsidies and Transfers?
Provide a short and direct response. -10.5. In the year 2012, what is the difference between the Expenses (% of total expenses) in Goods and services and Expenses (% of total expenses) in Other expenses?
Your answer should be very brief. 3.76. In the year 2012, what is the difference between the Expenses (% of total expenses) of Subsidies and Transfers and Expenses (% of total expenses) of Other expenses?
Make the answer very short. 14.26. What is the ratio of the Expenses (% of total expenses) in Compensation of employees in 2005 to that in 2006?
Keep it short and to the point. 0.98. What is the ratio of the Expenses (% of total expenses) of Goods and services in 2005 to that in 2006?
Offer a very short reply. 1.07. What is the ratio of the Expenses (% of total expenses) of Subsidies and Transfers in 2005 to that in 2006?
Offer a very short reply. 1.04. What is the ratio of the Expenses (% of total expenses) of Other expenses in 2005 to that in 2006?
Ensure brevity in your answer.  0.72. What is the ratio of the Expenses (% of total expenses) of Compensation of employees in 2005 to that in 2007?
Make the answer very short. 0.94. What is the ratio of the Expenses (% of total expenses) in Goods and services in 2005 to that in 2007?
Offer a terse response. 1.34. What is the ratio of the Expenses (% of total expenses) of Subsidies and Transfers in 2005 to that in 2007?
Your answer should be compact. 1.01. What is the ratio of the Expenses (% of total expenses) in Other expenses in 2005 to that in 2007?
Offer a very short reply. 0.67. What is the ratio of the Expenses (% of total expenses) of Compensation of employees in 2005 to that in 2008?
Give a very brief answer. 0.89. What is the ratio of the Expenses (% of total expenses) in Goods and services in 2005 to that in 2008?
Keep it short and to the point. 1.43. What is the ratio of the Expenses (% of total expenses) in Subsidies and Transfers in 2005 to that in 2008?
Provide a succinct answer. 1.08. What is the ratio of the Expenses (% of total expenses) of Other expenses in 2005 to that in 2008?
Your answer should be very brief. 0.63. What is the ratio of the Expenses (% of total expenses) in Compensation of employees in 2005 to that in 2009?
Your answer should be very brief. 0.92. What is the ratio of the Expenses (% of total expenses) of Goods and services in 2005 to that in 2009?
Offer a terse response. 1.17. What is the ratio of the Expenses (% of total expenses) in Subsidies and Transfers in 2005 to that in 2009?
Your response must be concise. 1.08. What is the ratio of the Expenses (% of total expenses) of Other expenses in 2005 to that in 2009?
Ensure brevity in your answer.  0.62. What is the ratio of the Expenses (% of total expenses) in Compensation of employees in 2005 to that in 2010?
Your answer should be compact. 0.88. What is the ratio of the Expenses (% of total expenses) of Goods and services in 2005 to that in 2010?
Ensure brevity in your answer.  1.17. What is the ratio of the Expenses (% of total expenses) of Subsidies and Transfers in 2005 to that in 2010?
Give a very brief answer. 1.11. What is the ratio of the Expenses (% of total expenses) in Other expenses in 2005 to that in 2010?
Give a very brief answer. 0.67. What is the ratio of the Expenses (% of total expenses) of Compensation of employees in 2005 to that in 2011?
Keep it short and to the point. 0.91. What is the ratio of the Expenses (% of total expenses) in Goods and services in 2005 to that in 2011?
Provide a succinct answer. 1.07. What is the ratio of the Expenses (% of total expenses) of Subsidies and Transfers in 2005 to that in 2011?
Your response must be concise. 1.13. What is the ratio of the Expenses (% of total expenses) in Other expenses in 2005 to that in 2011?
Give a very brief answer. 0.55. What is the ratio of the Expenses (% of total expenses) of Compensation of employees in 2005 to that in 2012?
Offer a terse response. 0.87. What is the ratio of the Expenses (% of total expenses) in Goods and services in 2005 to that in 2012?
Give a very brief answer. 1.23. What is the ratio of the Expenses (% of total expenses) in Subsidies and Transfers in 2005 to that in 2012?
Keep it short and to the point. 1.1. What is the ratio of the Expenses (% of total expenses) in Other expenses in 2005 to that in 2012?
Provide a succinct answer. 0.61. What is the ratio of the Expenses (% of total expenses) of Compensation of employees in 2006 to that in 2007?
Provide a succinct answer. 0.96. What is the ratio of the Expenses (% of total expenses) of Goods and services in 2006 to that in 2007?
Your answer should be very brief. 1.26. What is the ratio of the Expenses (% of total expenses) in Subsidies and Transfers in 2006 to that in 2007?
Your answer should be compact. 0.97. What is the ratio of the Expenses (% of total expenses) in Other expenses in 2006 to that in 2007?
Your answer should be very brief. 0.92. What is the ratio of the Expenses (% of total expenses) in Compensation of employees in 2006 to that in 2008?
Your answer should be very brief. 0.91. What is the ratio of the Expenses (% of total expenses) of Goods and services in 2006 to that in 2008?
Ensure brevity in your answer.  1.33. What is the ratio of the Expenses (% of total expenses) in Subsidies and Transfers in 2006 to that in 2008?
Ensure brevity in your answer.  1.04. What is the ratio of the Expenses (% of total expenses) in Other expenses in 2006 to that in 2008?
Your answer should be very brief. 0.87. What is the ratio of the Expenses (% of total expenses) in Compensation of employees in 2006 to that in 2009?
Offer a very short reply. 0.94. What is the ratio of the Expenses (% of total expenses) of Goods and services in 2006 to that in 2009?
Offer a terse response. 1.09. What is the ratio of the Expenses (% of total expenses) in Subsidies and Transfers in 2006 to that in 2009?
Offer a very short reply. 1.03. What is the ratio of the Expenses (% of total expenses) of Other expenses in 2006 to that in 2009?
Give a very brief answer. 0.86. What is the ratio of the Expenses (% of total expenses) in Compensation of employees in 2006 to that in 2010?
Offer a very short reply. 0.9. What is the ratio of the Expenses (% of total expenses) in Goods and services in 2006 to that in 2010?
Ensure brevity in your answer.  1.09. What is the ratio of the Expenses (% of total expenses) of Subsidies and Transfers in 2006 to that in 2010?
Your response must be concise. 1.07. What is the ratio of the Expenses (% of total expenses) of Other expenses in 2006 to that in 2010?
Your answer should be very brief. 0.93. What is the ratio of the Expenses (% of total expenses) of Compensation of employees in 2006 to that in 2011?
Provide a succinct answer. 0.93. What is the ratio of the Expenses (% of total expenses) of Goods and services in 2006 to that in 2011?
Your answer should be very brief. 1. What is the ratio of the Expenses (% of total expenses) in Subsidies and Transfers in 2006 to that in 2011?
Your answer should be compact. 1.09. What is the ratio of the Expenses (% of total expenses) in Other expenses in 2006 to that in 2011?
Offer a very short reply. 0.76. What is the ratio of the Expenses (% of total expenses) in Compensation of employees in 2006 to that in 2012?
Your response must be concise. 0.89. What is the ratio of the Expenses (% of total expenses) of Goods and services in 2006 to that in 2012?
Give a very brief answer. 1.15. What is the ratio of the Expenses (% of total expenses) in Subsidies and Transfers in 2006 to that in 2012?
Keep it short and to the point. 1.06. What is the ratio of the Expenses (% of total expenses) of Other expenses in 2006 to that in 2012?
Provide a succinct answer. 0.84. What is the ratio of the Expenses (% of total expenses) of Compensation of employees in 2007 to that in 2008?
Provide a short and direct response. 0.95. What is the ratio of the Expenses (% of total expenses) of Goods and services in 2007 to that in 2008?
Your answer should be very brief. 1.06. What is the ratio of the Expenses (% of total expenses) of Subsidies and Transfers in 2007 to that in 2008?
Give a very brief answer. 1.07. What is the ratio of the Expenses (% of total expenses) in Other expenses in 2007 to that in 2008?
Offer a very short reply. 0.95. What is the ratio of the Expenses (% of total expenses) of Compensation of employees in 2007 to that in 2009?
Make the answer very short. 0.98. What is the ratio of the Expenses (% of total expenses) of Goods and services in 2007 to that in 2009?
Make the answer very short. 0.87. What is the ratio of the Expenses (% of total expenses) in Subsidies and Transfers in 2007 to that in 2009?
Keep it short and to the point. 1.07. What is the ratio of the Expenses (% of total expenses) in Other expenses in 2007 to that in 2009?
Make the answer very short. 0.94. What is the ratio of the Expenses (% of total expenses) of Compensation of employees in 2007 to that in 2010?
Give a very brief answer. 0.94. What is the ratio of the Expenses (% of total expenses) of Goods and services in 2007 to that in 2010?
Offer a terse response. 0.87. What is the ratio of the Expenses (% of total expenses) in Subsidies and Transfers in 2007 to that in 2010?
Keep it short and to the point. 1.11. What is the ratio of the Expenses (% of total expenses) of Other expenses in 2007 to that in 2010?
Ensure brevity in your answer.  1.01. What is the ratio of the Expenses (% of total expenses) in Compensation of employees in 2007 to that in 2011?
Keep it short and to the point. 0.97. What is the ratio of the Expenses (% of total expenses) of Goods and services in 2007 to that in 2011?
Give a very brief answer. 0.8. What is the ratio of the Expenses (% of total expenses) in Subsidies and Transfers in 2007 to that in 2011?
Provide a succinct answer. 1.12. What is the ratio of the Expenses (% of total expenses) in Other expenses in 2007 to that in 2011?
Ensure brevity in your answer.  0.82. What is the ratio of the Expenses (% of total expenses) in Compensation of employees in 2007 to that in 2012?
Provide a succinct answer. 0.92. What is the ratio of the Expenses (% of total expenses) of Goods and services in 2007 to that in 2012?
Provide a short and direct response. 0.91. What is the ratio of the Expenses (% of total expenses) of Subsidies and Transfers in 2007 to that in 2012?
Offer a very short reply. 1.09. What is the ratio of the Expenses (% of total expenses) of Other expenses in 2007 to that in 2012?
Give a very brief answer. 0.91. What is the ratio of the Expenses (% of total expenses) of Compensation of employees in 2008 to that in 2009?
Provide a short and direct response. 1.03. What is the ratio of the Expenses (% of total expenses) of Goods and services in 2008 to that in 2009?
Provide a succinct answer. 0.82. What is the ratio of the Expenses (% of total expenses) of Other expenses in 2008 to that in 2009?
Give a very brief answer. 0.99. What is the ratio of the Expenses (% of total expenses) of Compensation of employees in 2008 to that in 2010?
Offer a terse response. 0.99. What is the ratio of the Expenses (% of total expenses) of Goods and services in 2008 to that in 2010?
Your response must be concise. 0.82. What is the ratio of the Expenses (% of total expenses) of Subsidies and Transfers in 2008 to that in 2010?
Provide a succinct answer. 1.03. What is the ratio of the Expenses (% of total expenses) of Other expenses in 2008 to that in 2010?
Ensure brevity in your answer.  1.07. What is the ratio of the Expenses (% of total expenses) of Compensation of employees in 2008 to that in 2011?
Your answer should be very brief. 1.02. What is the ratio of the Expenses (% of total expenses) in Goods and services in 2008 to that in 2011?
Your response must be concise. 0.75. What is the ratio of the Expenses (% of total expenses) of Subsidies and Transfers in 2008 to that in 2011?
Your answer should be compact. 1.05. What is the ratio of the Expenses (% of total expenses) in Other expenses in 2008 to that in 2011?
Offer a very short reply. 0.87. What is the ratio of the Expenses (% of total expenses) in Compensation of employees in 2008 to that in 2012?
Make the answer very short. 0.98. What is the ratio of the Expenses (% of total expenses) in Goods and services in 2008 to that in 2012?
Offer a terse response. 0.86. What is the ratio of the Expenses (% of total expenses) of Subsidies and Transfers in 2008 to that in 2012?
Your answer should be compact. 1.02. What is the ratio of the Expenses (% of total expenses) in Other expenses in 2008 to that in 2012?
Your answer should be very brief. 0.97. What is the ratio of the Expenses (% of total expenses) in Compensation of employees in 2009 to that in 2010?
Ensure brevity in your answer.  0.96. What is the ratio of the Expenses (% of total expenses) in Subsidies and Transfers in 2009 to that in 2010?
Offer a terse response. 1.03. What is the ratio of the Expenses (% of total expenses) in Other expenses in 2009 to that in 2010?
Offer a very short reply. 1.08. What is the ratio of the Expenses (% of total expenses) in Goods and services in 2009 to that in 2011?
Your answer should be very brief. 0.92. What is the ratio of the Expenses (% of total expenses) in Subsidies and Transfers in 2009 to that in 2011?
Your answer should be compact. 1.05. What is the ratio of the Expenses (% of total expenses) of Other expenses in 2009 to that in 2011?
Ensure brevity in your answer.  0.88. What is the ratio of the Expenses (% of total expenses) in Compensation of employees in 2009 to that in 2012?
Offer a terse response. 0.95. What is the ratio of the Expenses (% of total expenses) of Goods and services in 2009 to that in 2012?
Offer a very short reply. 1.05. What is the ratio of the Expenses (% of total expenses) of Subsidies and Transfers in 2009 to that in 2012?
Provide a succinct answer. 1.02. What is the ratio of the Expenses (% of total expenses) in Other expenses in 2009 to that in 2012?
Your answer should be compact. 0.98. What is the ratio of the Expenses (% of total expenses) of Compensation of employees in 2010 to that in 2011?
Offer a terse response. 1.03. What is the ratio of the Expenses (% of total expenses) of Goods and services in 2010 to that in 2011?
Provide a succinct answer. 0.92. What is the ratio of the Expenses (% of total expenses) of Subsidies and Transfers in 2010 to that in 2011?
Make the answer very short. 1.01. What is the ratio of the Expenses (% of total expenses) of Other expenses in 2010 to that in 2011?
Ensure brevity in your answer.  0.81. What is the ratio of the Expenses (% of total expenses) of Goods and services in 2010 to that in 2012?
Ensure brevity in your answer.  1.05. What is the ratio of the Expenses (% of total expenses) of Other expenses in 2010 to that in 2012?
Give a very brief answer. 0.9. What is the ratio of the Expenses (% of total expenses) of Compensation of employees in 2011 to that in 2012?
Keep it short and to the point. 0.95. What is the ratio of the Expenses (% of total expenses) in Goods and services in 2011 to that in 2012?
Ensure brevity in your answer.  1.15. What is the ratio of the Expenses (% of total expenses) of Subsidies and Transfers in 2011 to that in 2012?
Your answer should be compact. 0.98. What is the ratio of the Expenses (% of total expenses) in Other expenses in 2011 to that in 2012?
Offer a very short reply. 1.11. What is the difference between the highest and the second highest Expenses (% of total expenses) in Compensation of employees?
Your answer should be compact. 0.73. What is the difference between the highest and the second highest Expenses (% of total expenses) of Goods and services?
Provide a short and direct response. 0.98. What is the difference between the highest and the second highest Expenses (% of total expenses) of Subsidies and Transfers?
Make the answer very short. 0.2. What is the difference between the highest and the second highest Expenses (% of total expenses) in Other expenses?
Offer a terse response. 0.91. What is the difference between the highest and the lowest Expenses (% of total expenses) in Compensation of employees?
Ensure brevity in your answer.  7.34. What is the difference between the highest and the lowest Expenses (% of total expenses) in Goods and services?
Give a very brief answer. 4.46. What is the difference between the highest and the lowest Expenses (% of total expenses) of Subsidies and Transfers?
Provide a short and direct response. 2.88. What is the difference between the highest and the lowest Expenses (% of total expenses) in Other expenses?
Provide a short and direct response. 4.19. 